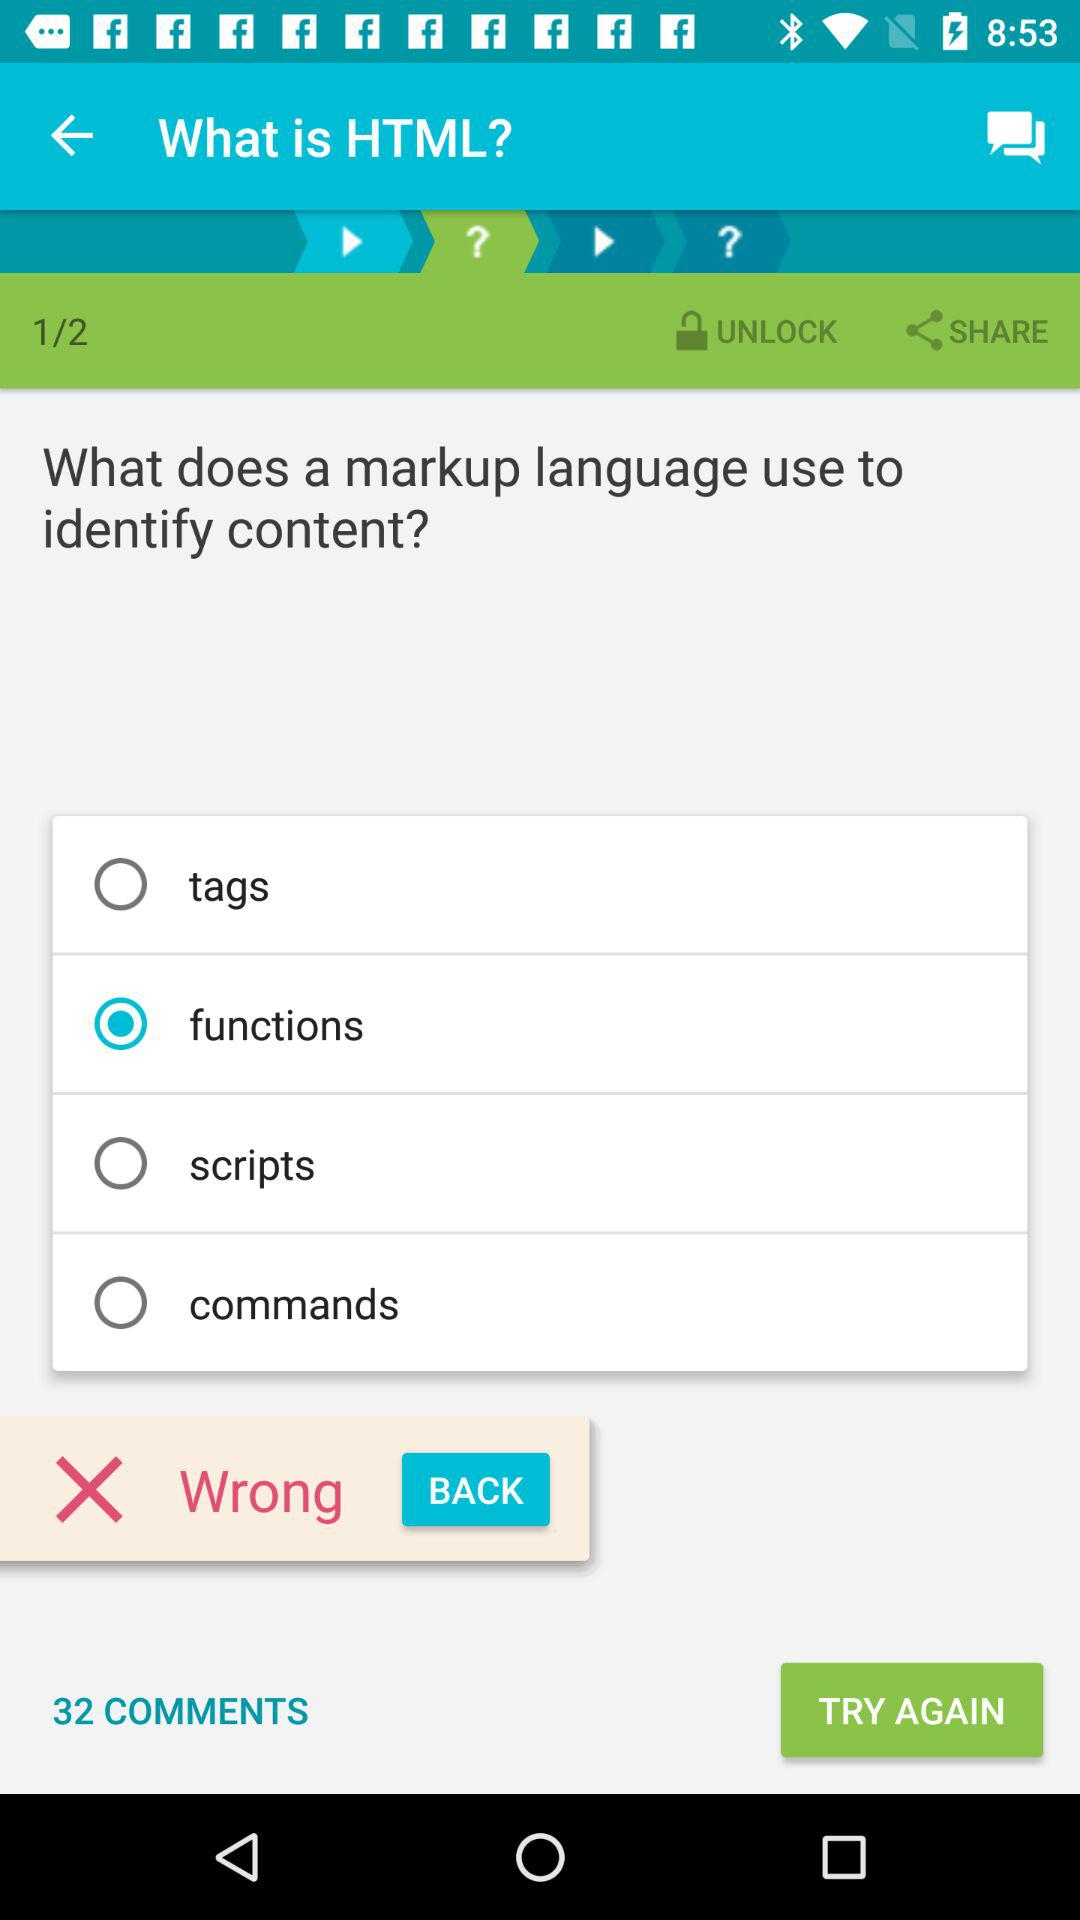Which is the current page number? The current page number is 1. 